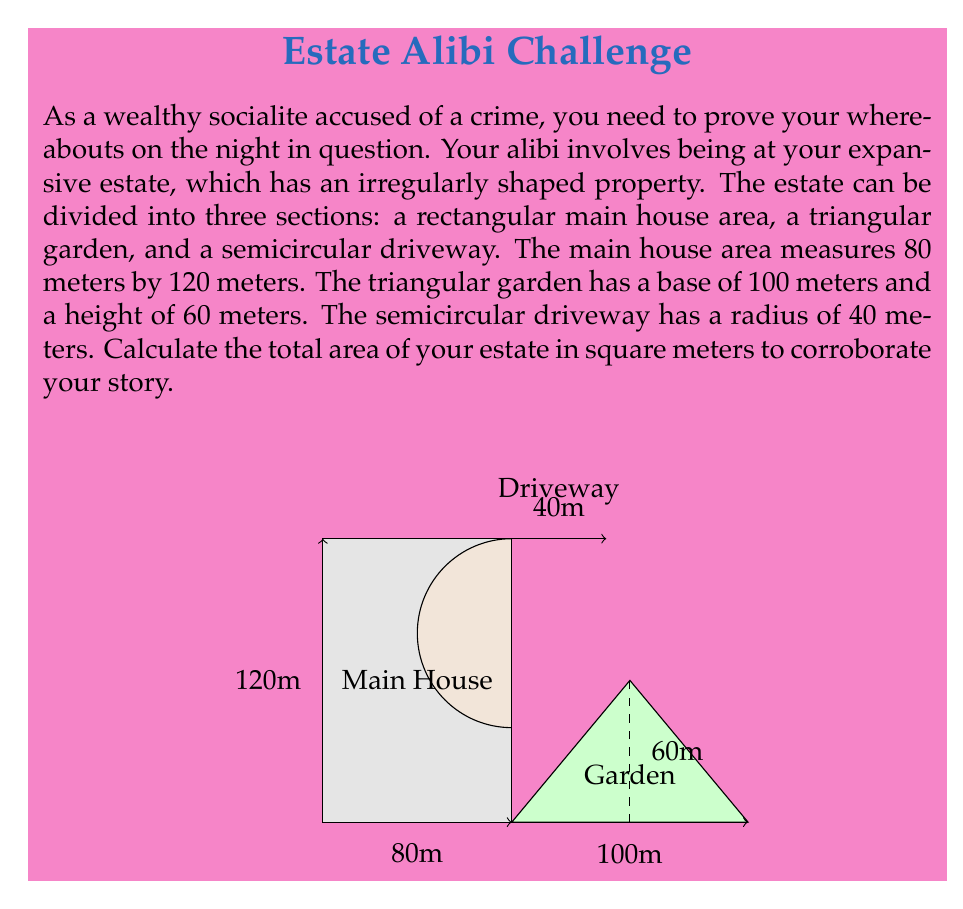Could you help me with this problem? To find the total area of the estate, we need to calculate the areas of each section and sum them up:

1. Area of the rectangular main house:
   $A_{house} = l \times w = 80 \times 120 = 9600$ square meters

2. Area of the triangular garden:
   $A_{garden} = \frac{1}{2} \times base \times height = \frac{1}{2} \times 100 \times 60 = 3000$ square meters

3. Area of the semicircular driveway:
   $A_{driveway} = \frac{1}{2} \times \pi r^2 = \frac{1}{2} \times \pi \times 40^2 = 2513.27$ square meters (rounded to 2 decimal places)

Total area of the estate:
$$A_{total} = A_{house} + A_{garden} + A_{driveway}$$
$$A_{total} = 9600 + 3000 + 2513.27 = 15113.27$$ square meters

Therefore, the total area of your estate is approximately 15,113.27 square meters.
Answer: 15,113.27 square meters 